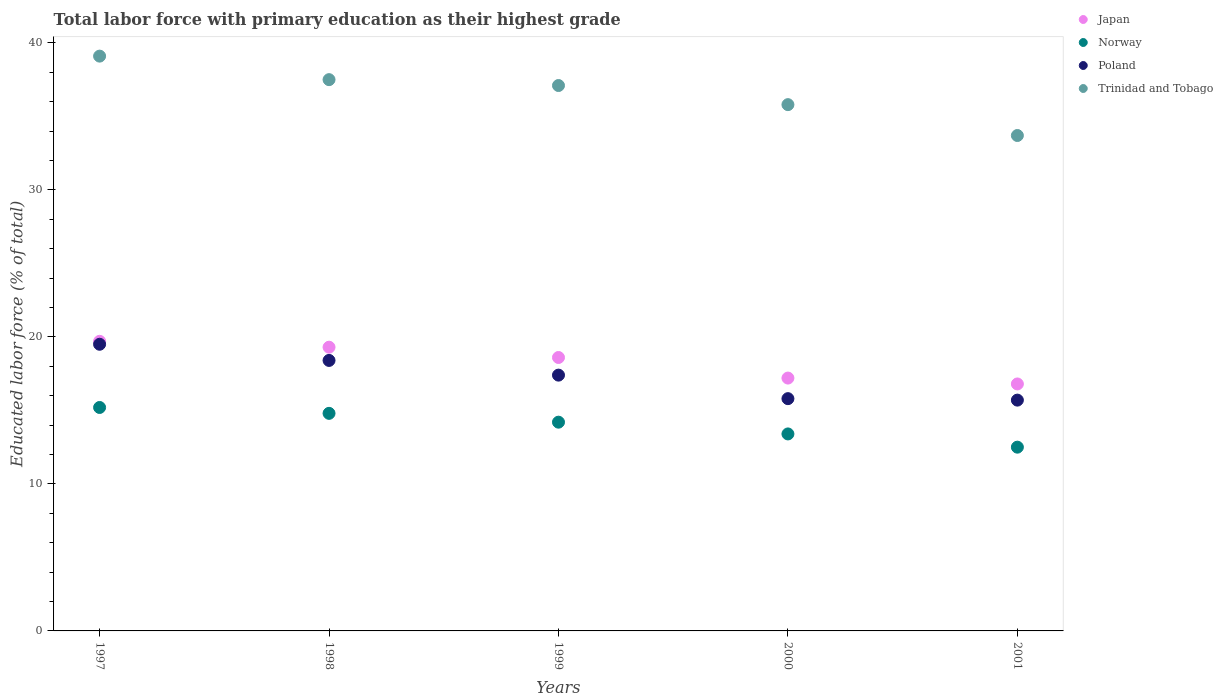What is the percentage of total labor force with primary education in Poland in 2000?
Make the answer very short. 15.8. Across all years, what is the maximum percentage of total labor force with primary education in Trinidad and Tobago?
Keep it short and to the point. 39.1. Across all years, what is the minimum percentage of total labor force with primary education in Trinidad and Tobago?
Offer a very short reply. 33.7. In which year was the percentage of total labor force with primary education in Norway maximum?
Give a very brief answer. 1997. In which year was the percentage of total labor force with primary education in Japan minimum?
Your answer should be compact. 2001. What is the total percentage of total labor force with primary education in Norway in the graph?
Give a very brief answer. 70.1. What is the difference between the percentage of total labor force with primary education in Trinidad and Tobago in 1998 and that in 2001?
Your answer should be very brief. 3.8. What is the difference between the percentage of total labor force with primary education in Japan in 2000 and the percentage of total labor force with primary education in Norway in 2001?
Provide a short and direct response. 4.7. What is the average percentage of total labor force with primary education in Japan per year?
Provide a succinct answer. 18.32. In the year 1997, what is the difference between the percentage of total labor force with primary education in Norway and percentage of total labor force with primary education in Japan?
Ensure brevity in your answer.  -4.5. In how many years, is the percentage of total labor force with primary education in Japan greater than 12 %?
Your answer should be very brief. 5. What is the ratio of the percentage of total labor force with primary education in Japan in 1998 to that in 1999?
Offer a terse response. 1.04. Is the percentage of total labor force with primary education in Poland in 1998 less than that in 2001?
Your answer should be very brief. No. What is the difference between the highest and the second highest percentage of total labor force with primary education in Poland?
Offer a very short reply. 1.1. What is the difference between the highest and the lowest percentage of total labor force with primary education in Norway?
Provide a short and direct response. 2.7. Is the sum of the percentage of total labor force with primary education in Trinidad and Tobago in 1997 and 1999 greater than the maximum percentage of total labor force with primary education in Japan across all years?
Offer a terse response. Yes. Is it the case that in every year, the sum of the percentage of total labor force with primary education in Norway and percentage of total labor force with primary education in Japan  is greater than the sum of percentage of total labor force with primary education in Trinidad and Tobago and percentage of total labor force with primary education in Poland?
Offer a very short reply. No. Is the percentage of total labor force with primary education in Poland strictly greater than the percentage of total labor force with primary education in Norway over the years?
Offer a terse response. Yes. How many dotlines are there?
Ensure brevity in your answer.  4. How many years are there in the graph?
Your answer should be compact. 5. What is the difference between two consecutive major ticks on the Y-axis?
Your answer should be very brief. 10. Are the values on the major ticks of Y-axis written in scientific E-notation?
Your response must be concise. No. Does the graph contain grids?
Offer a very short reply. No. Where does the legend appear in the graph?
Ensure brevity in your answer.  Top right. What is the title of the graph?
Ensure brevity in your answer.  Total labor force with primary education as their highest grade. Does "Germany" appear as one of the legend labels in the graph?
Give a very brief answer. No. What is the label or title of the Y-axis?
Ensure brevity in your answer.  Educated labor force (% of total). What is the Educated labor force (% of total) in Japan in 1997?
Keep it short and to the point. 19.7. What is the Educated labor force (% of total) in Norway in 1997?
Keep it short and to the point. 15.2. What is the Educated labor force (% of total) of Trinidad and Tobago in 1997?
Your response must be concise. 39.1. What is the Educated labor force (% of total) of Japan in 1998?
Your answer should be very brief. 19.3. What is the Educated labor force (% of total) of Norway in 1998?
Offer a very short reply. 14.8. What is the Educated labor force (% of total) in Poland in 1998?
Your response must be concise. 18.4. What is the Educated labor force (% of total) of Trinidad and Tobago in 1998?
Ensure brevity in your answer.  37.5. What is the Educated labor force (% of total) in Japan in 1999?
Give a very brief answer. 18.6. What is the Educated labor force (% of total) of Norway in 1999?
Offer a very short reply. 14.2. What is the Educated labor force (% of total) of Poland in 1999?
Your answer should be compact. 17.4. What is the Educated labor force (% of total) in Trinidad and Tobago in 1999?
Make the answer very short. 37.1. What is the Educated labor force (% of total) in Japan in 2000?
Your answer should be compact. 17.2. What is the Educated labor force (% of total) of Norway in 2000?
Ensure brevity in your answer.  13.4. What is the Educated labor force (% of total) of Poland in 2000?
Your response must be concise. 15.8. What is the Educated labor force (% of total) in Trinidad and Tobago in 2000?
Offer a terse response. 35.8. What is the Educated labor force (% of total) in Japan in 2001?
Offer a terse response. 16.8. What is the Educated labor force (% of total) of Norway in 2001?
Ensure brevity in your answer.  12.5. What is the Educated labor force (% of total) of Poland in 2001?
Provide a short and direct response. 15.7. What is the Educated labor force (% of total) in Trinidad and Tobago in 2001?
Give a very brief answer. 33.7. Across all years, what is the maximum Educated labor force (% of total) of Japan?
Provide a succinct answer. 19.7. Across all years, what is the maximum Educated labor force (% of total) of Norway?
Your answer should be very brief. 15.2. Across all years, what is the maximum Educated labor force (% of total) of Poland?
Your answer should be compact. 19.5. Across all years, what is the maximum Educated labor force (% of total) in Trinidad and Tobago?
Give a very brief answer. 39.1. Across all years, what is the minimum Educated labor force (% of total) of Japan?
Your response must be concise. 16.8. Across all years, what is the minimum Educated labor force (% of total) of Norway?
Make the answer very short. 12.5. Across all years, what is the minimum Educated labor force (% of total) in Poland?
Provide a succinct answer. 15.7. Across all years, what is the minimum Educated labor force (% of total) of Trinidad and Tobago?
Make the answer very short. 33.7. What is the total Educated labor force (% of total) of Japan in the graph?
Your answer should be very brief. 91.6. What is the total Educated labor force (% of total) in Norway in the graph?
Provide a succinct answer. 70.1. What is the total Educated labor force (% of total) of Poland in the graph?
Your answer should be compact. 86.8. What is the total Educated labor force (% of total) of Trinidad and Tobago in the graph?
Your answer should be compact. 183.2. What is the difference between the Educated labor force (% of total) in Norway in 1997 and that in 1998?
Your answer should be compact. 0.4. What is the difference between the Educated labor force (% of total) in Trinidad and Tobago in 1997 and that in 1998?
Your answer should be very brief. 1.6. What is the difference between the Educated labor force (% of total) of Norway in 1997 and that in 1999?
Offer a very short reply. 1. What is the difference between the Educated labor force (% of total) of Trinidad and Tobago in 1997 and that in 1999?
Your answer should be compact. 2. What is the difference between the Educated labor force (% of total) in Japan in 1997 and that in 2000?
Make the answer very short. 2.5. What is the difference between the Educated labor force (% of total) in Trinidad and Tobago in 1997 and that in 2000?
Offer a terse response. 3.3. What is the difference between the Educated labor force (% of total) in Trinidad and Tobago in 1997 and that in 2001?
Offer a very short reply. 5.4. What is the difference between the Educated labor force (% of total) in Japan in 1998 and that in 1999?
Provide a succinct answer. 0.7. What is the difference between the Educated labor force (% of total) in Norway in 1998 and that in 1999?
Keep it short and to the point. 0.6. What is the difference between the Educated labor force (% of total) of Trinidad and Tobago in 1998 and that in 1999?
Make the answer very short. 0.4. What is the difference between the Educated labor force (% of total) of Japan in 1998 and that in 2000?
Provide a short and direct response. 2.1. What is the difference between the Educated labor force (% of total) in Poland in 1998 and that in 2000?
Your response must be concise. 2.6. What is the difference between the Educated labor force (% of total) of Norway in 1998 and that in 2001?
Offer a terse response. 2.3. What is the difference between the Educated labor force (% of total) in Poland in 1998 and that in 2001?
Your response must be concise. 2.7. What is the difference between the Educated labor force (% of total) of Japan in 1999 and that in 2000?
Offer a terse response. 1.4. What is the difference between the Educated labor force (% of total) in Trinidad and Tobago in 1999 and that in 2000?
Ensure brevity in your answer.  1.3. What is the difference between the Educated labor force (% of total) in Japan in 1999 and that in 2001?
Keep it short and to the point. 1.8. What is the difference between the Educated labor force (% of total) in Norway in 1999 and that in 2001?
Your response must be concise. 1.7. What is the difference between the Educated labor force (% of total) of Trinidad and Tobago in 1999 and that in 2001?
Your answer should be compact. 3.4. What is the difference between the Educated labor force (% of total) of Japan in 2000 and that in 2001?
Ensure brevity in your answer.  0.4. What is the difference between the Educated labor force (% of total) in Poland in 2000 and that in 2001?
Your answer should be very brief. 0.1. What is the difference between the Educated labor force (% of total) of Japan in 1997 and the Educated labor force (% of total) of Poland in 1998?
Give a very brief answer. 1.3. What is the difference between the Educated labor force (% of total) in Japan in 1997 and the Educated labor force (% of total) in Trinidad and Tobago in 1998?
Your response must be concise. -17.8. What is the difference between the Educated labor force (% of total) in Norway in 1997 and the Educated labor force (% of total) in Poland in 1998?
Make the answer very short. -3.2. What is the difference between the Educated labor force (% of total) of Norway in 1997 and the Educated labor force (% of total) of Trinidad and Tobago in 1998?
Offer a very short reply. -22.3. What is the difference between the Educated labor force (% of total) in Japan in 1997 and the Educated labor force (% of total) in Poland in 1999?
Your answer should be compact. 2.3. What is the difference between the Educated labor force (% of total) of Japan in 1997 and the Educated labor force (% of total) of Trinidad and Tobago in 1999?
Provide a short and direct response. -17.4. What is the difference between the Educated labor force (% of total) in Norway in 1997 and the Educated labor force (% of total) in Trinidad and Tobago in 1999?
Offer a very short reply. -21.9. What is the difference between the Educated labor force (% of total) of Poland in 1997 and the Educated labor force (% of total) of Trinidad and Tobago in 1999?
Your answer should be very brief. -17.6. What is the difference between the Educated labor force (% of total) in Japan in 1997 and the Educated labor force (% of total) in Norway in 2000?
Provide a short and direct response. 6.3. What is the difference between the Educated labor force (% of total) in Japan in 1997 and the Educated labor force (% of total) in Poland in 2000?
Your answer should be compact. 3.9. What is the difference between the Educated labor force (% of total) of Japan in 1997 and the Educated labor force (% of total) of Trinidad and Tobago in 2000?
Keep it short and to the point. -16.1. What is the difference between the Educated labor force (% of total) of Norway in 1997 and the Educated labor force (% of total) of Trinidad and Tobago in 2000?
Make the answer very short. -20.6. What is the difference between the Educated labor force (% of total) in Poland in 1997 and the Educated labor force (% of total) in Trinidad and Tobago in 2000?
Give a very brief answer. -16.3. What is the difference between the Educated labor force (% of total) in Norway in 1997 and the Educated labor force (% of total) in Trinidad and Tobago in 2001?
Ensure brevity in your answer.  -18.5. What is the difference between the Educated labor force (% of total) of Japan in 1998 and the Educated labor force (% of total) of Poland in 1999?
Provide a succinct answer. 1.9. What is the difference between the Educated labor force (% of total) of Japan in 1998 and the Educated labor force (% of total) of Trinidad and Tobago in 1999?
Provide a succinct answer. -17.8. What is the difference between the Educated labor force (% of total) in Norway in 1998 and the Educated labor force (% of total) in Poland in 1999?
Offer a very short reply. -2.6. What is the difference between the Educated labor force (% of total) in Norway in 1998 and the Educated labor force (% of total) in Trinidad and Tobago in 1999?
Offer a terse response. -22.3. What is the difference between the Educated labor force (% of total) in Poland in 1998 and the Educated labor force (% of total) in Trinidad and Tobago in 1999?
Your answer should be compact. -18.7. What is the difference between the Educated labor force (% of total) of Japan in 1998 and the Educated labor force (% of total) of Norway in 2000?
Your answer should be compact. 5.9. What is the difference between the Educated labor force (% of total) of Japan in 1998 and the Educated labor force (% of total) of Trinidad and Tobago in 2000?
Ensure brevity in your answer.  -16.5. What is the difference between the Educated labor force (% of total) of Norway in 1998 and the Educated labor force (% of total) of Poland in 2000?
Your answer should be very brief. -1. What is the difference between the Educated labor force (% of total) of Poland in 1998 and the Educated labor force (% of total) of Trinidad and Tobago in 2000?
Your answer should be very brief. -17.4. What is the difference between the Educated labor force (% of total) in Japan in 1998 and the Educated labor force (% of total) in Trinidad and Tobago in 2001?
Offer a terse response. -14.4. What is the difference between the Educated labor force (% of total) in Norway in 1998 and the Educated labor force (% of total) in Trinidad and Tobago in 2001?
Your answer should be very brief. -18.9. What is the difference between the Educated labor force (% of total) of Poland in 1998 and the Educated labor force (% of total) of Trinidad and Tobago in 2001?
Your answer should be very brief. -15.3. What is the difference between the Educated labor force (% of total) of Japan in 1999 and the Educated labor force (% of total) of Poland in 2000?
Offer a very short reply. 2.8. What is the difference between the Educated labor force (% of total) in Japan in 1999 and the Educated labor force (% of total) in Trinidad and Tobago in 2000?
Your answer should be compact. -17.2. What is the difference between the Educated labor force (% of total) of Norway in 1999 and the Educated labor force (% of total) of Trinidad and Tobago in 2000?
Your response must be concise. -21.6. What is the difference between the Educated labor force (% of total) in Poland in 1999 and the Educated labor force (% of total) in Trinidad and Tobago in 2000?
Provide a succinct answer. -18.4. What is the difference between the Educated labor force (% of total) of Japan in 1999 and the Educated labor force (% of total) of Poland in 2001?
Provide a succinct answer. 2.9. What is the difference between the Educated labor force (% of total) of Japan in 1999 and the Educated labor force (% of total) of Trinidad and Tobago in 2001?
Your answer should be compact. -15.1. What is the difference between the Educated labor force (% of total) in Norway in 1999 and the Educated labor force (% of total) in Poland in 2001?
Provide a short and direct response. -1.5. What is the difference between the Educated labor force (% of total) in Norway in 1999 and the Educated labor force (% of total) in Trinidad and Tobago in 2001?
Offer a terse response. -19.5. What is the difference between the Educated labor force (% of total) in Poland in 1999 and the Educated labor force (% of total) in Trinidad and Tobago in 2001?
Give a very brief answer. -16.3. What is the difference between the Educated labor force (% of total) in Japan in 2000 and the Educated labor force (% of total) in Norway in 2001?
Give a very brief answer. 4.7. What is the difference between the Educated labor force (% of total) in Japan in 2000 and the Educated labor force (% of total) in Trinidad and Tobago in 2001?
Your answer should be very brief. -16.5. What is the difference between the Educated labor force (% of total) in Norway in 2000 and the Educated labor force (% of total) in Poland in 2001?
Your answer should be compact. -2.3. What is the difference between the Educated labor force (% of total) in Norway in 2000 and the Educated labor force (% of total) in Trinidad and Tobago in 2001?
Keep it short and to the point. -20.3. What is the difference between the Educated labor force (% of total) of Poland in 2000 and the Educated labor force (% of total) of Trinidad and Tobago in 2001?
Ensure brevity in your answer.  -17.9. What is the average Educated labor force (% of total) in Japan per year?
Your answer should be compact. 18.32. What is the average Educated labor force (% of total) of Norway per year?
Make the answer very short. 14.02. What is the average Educated labor force (% of total) in Poland per year?
Make the answer very short. 17.36. What is the average Educated labor force (% of total) in Trinidad and Tobago per year?
Your answer should be very brief. 36.64. In the year 1997, what is the difference between the Educated labor force (% of total) of Japan and Educated labor force (% of total) of Trinidad and Tobago?
Your answer should be very brief. -19.4. In the year 1997, what is the difference between the Educated labor force (% of total) of Norway and Educated labor force (% of total) of Poland?
Your response must be concise. -4.3. In the year 1997, what is the difference between the Educated labor force (% of total) of Norway and Educated labor force (% of total) of Trinidad and Tobago?
Offer a very short reply. -23.9. In the year 1997, what is the difference between the Educated labor force (% of total) in Poland and Educated labor force (% of total) in Trinidad and Tobago?
Keep it short and to the point. -19.6. In the year 1998, what is the difference between the Educated labor force (% of total) of Japan and Educated labor force (% of total) of Norway?
Make the answer very short. 4.5. In the year 1998, what is the difference between the Educated labor force (% of total) in Japan and Educated labor force (% of total) in Poland?
Ensure brevity in your answer.  0.9. In the year 1998, what is the difference between the Educated labor force (% of total) in Japan and Educated labor force (% of total) in Trinidad and Tobago?
Provide a succinct answer. -18.2. In the year 1998, what is the difference between the Educated labor force (% of total) in Norway and Educated labor force (% of total) in Poland?
Offer a terse response. -3.6. In the year 1998, what is the difference between the Educated labor force (% of total) of Norway and Educated labor force (% of total) of Trinidad and Tobago?
Offer a terse response. -22.7. In the year 1998, what is the difference between the Educated labor force (% of total) of Poland and Educated labor force (% of total) of Trinidad and Tobago?
Your answer should be very brief. -19.1. In the year 1999, what is the difference between the Educated labor force (% of total) of Japan and Educated labor force (% of total) of Poland?
Your response must be concise. 1.2. In the year 1999, what is the difference between the Educated labor force (% of total) in Japan and Educated labor force (% of total) in Trinidad and Tobago?
Offer a very short reply. -18.5. In the year 1999, what is the difference between the Educated labor force (% of total) of Norway and Educated labor force (% of total) of Poland?
Your answer should be very brief. -3.2. In the year 1999, what is the difference between the Educated labor force (% of total) of Norway and Educated labor force (% of total) of Trinidad and Tobago?
Provide a succinct answer. -22.9. In the year 1999, what is the difference between the Educated labor force (% of total) in Poland and Educated labor force (% of total) in Trinidad and Tobago?
Your answer should be very brief. -19.7. In the year 2000, what is the difference between the Educated labor force (% of total) in Japan and Educated labor force (% of total) in Poland?
Provide a short and direct response. 1.4. In the year 2000, what is the difference between the Educated labor force (% of total) in Japan and Educated labor force (% of total) in Trinidad and Tobago?
Keep it short and to the point. -18.6. In the year 2000, what is the difference between the Educated labor force (% of total) of Norway and Educated labor force (% of total) of Trinidad and Tobago?
Your answer should be very brief. -22.4. In the year 2001, what is the difference between the Educated labor force (% of total) in Japan and Educated labor force (% of total) in Trinidad and Tobago?
Provide a succinct answer. -16.9. In the year 2001, what is the difference between the Educated labor force (% of total) of Norway and Educated labor force (% of total) of Trinidad and Tobago?
Your response must be concise. -21.2. What is the ratio of the Educated labor force (% of total) in Japan in 1997 to that in 1998?
Your answer should be very brief. 1.02. What is the ratio of the Educated labor force (% of total) of Norway in 1997 to that in 1998?
Ensure brevity in your answer.  1.03. What is the ratio of the Educated labor force (% of total) in Poland in 1997 to that in 1998?
Ensure brevity in your answer.  1.06. What is the ratio of the Educated labor force (% of total) in Trinidad and Tobago in 1997 to that in 1998?
Provide a short and direct response. 1.04. What is the ratio of the Educated labor force (% of total) in Japan in 1997 to that in 1999?
Provide a succinct answer. 1.06. What is the ratio of the Educated labor force (% of total) in Norway in 1997 to that in 1999?
Offer a very short reply. 1.07. What is the ratio of the Educated labor force (% of total) of Poland in 1997 to that in 1999?
Keep it short and to the point. 1.12. What is the ratio of the Educated labor force (% of total) in Trinidad and Tobago in 1997 to that in 1999?
Keep it short and to the point. 1.05. What is the ratio of the Educated labor force (% of total) in Japan in 1997 to that in 2000?
Your answer should be very brief. 1.15. What is the ratio of the Educated labor force (% of total) in Norway in 1997 to that in 2000?
Ensure brevity in your answer.  1.13. What is the ratio of the Educated labor force (% of total) of Poland in 1997 to that in 2000?
Your response must be concise. 1.23. What is the ratio of the Educated labor force (% of total) of Trinidad and Tobago in 1997 to that in 2000?
Offer a very short reply. 1.09. What is the ratio of the Educated labor force (% of total) in Japan in 1997 to that in 2001?
Provide a succinct answer. 1.17. What is the ratio of the Educated labor force (% of total) of Norway in 1997 to that in 2001?
Your response must be concise. 1.22. What is the ratio of the Educated labor force (% of total) in Poland in 1997 to that in 2001?
Your answer should be very brief. 1.24. What is the ratio of the Educated labor force (% of total) in Trinidad and Tobago in 1997 to that in 2001?
Offer a very short reply. 1.16. What is the ratio of the Educated labor force (% of total) of Japan in 1998 to that in 1999?
Your answer should be very brief. 1.04. What is the ratio of the Educated labor force (% of total) in Norway in 1998 to that in 1999?
Offer a terse response. 1.04. What is the ratio of the Educated labor force (% of total) of Poland in 1998 to that in 1999?
Offer a very short reply. 1.06. What is the ratio of the Educated labor force (% of total) of Trinidad and Tobago in 1998 to that in 1999?
Your response must be concise. 1.01. What is the ratio of the Educated labor force (% of total) in Japan in 1998 to that in 2000?
Provide a succinct answer. 1.12. What is the ratio of the Educated labor force (% of total) of Norway in 1998 to that in 2000?
Provide a short and direct response. 1.1. What is the ratio of the Educated labor force (% of total) of Poland in 1998 to that in 2000?
Provide a succinct answer. 1.16. What is the ratio of the Educated labor force (% of total) of Trinidad and Tobago in 1998 to that in 2000?
Your answer should be very brief. 1.05. What is the ratio of the Educated labor force (% of total) in Japan in 1998 to that in 2001?
Offer a very short reply. 1.15. What is the ratio of the Educated labor force (% of total) in Norway in 1998 to that in 2001?
Ensure brevity in your answer.  1.18. What is the ratio of the Educated labor force (% of total) in Poland in 1998 to that in 2001?
Offer a terse response. 1.17. What is the ratio of the Educated labor force (% of total) of Trinidad and Tobago in 1998 to that in 2001?
Provide a succinct answer. 1.11. What is the ratio of the Educated labor force (% of total) of Japan in 1999 to that in 2000?
Your answer should be compact. 1.08. What is the ratio of the Educated labor force (% of total) in Norway in 1999 to that in 2000?
Provide a succinct answer. 1.06. What is the ratio of the Educated labor force (% of total) in Poland in 1999 to that in 2000?
Ensure brevity in your answer.  1.1. What is the ratio of the Educated labor force (% of total) in Trinidad and Tobago in 1999 to that in 2000?
Provide a short and direct response. 1.04. What is the ratio of the Educated labor force (% of total) of Japan in 1999 to that in 2001?
Offer a very short reply. 1.11. What is the ratio of the Educated labor force (% of total) of Norway in 1999 to that in 2001?
Offer a very short reply. 1.14. What is the ratio of the Educated labor force (% of total) in Poland in 1999 to that in 2001?
Give a very brief answer. 1.11. What is the ratio of the Educated labor force (% of total) in Trinidad and Tobago in 1999 to that in 2001?
Offer a terse response. 1.1. What is the ratio of the Educated labor force (% of total) of Japan in 2000 to that in 2001?
Give a very brief answer. 1.02. What is the ratio of the Educated labor force (% of total) in Norway in 2000 to that in 2001?
Offer a very short reply. 1.07. What is the ratio of the Educated labor force (% of total) in Poland in 2000 to that in 2001?
Offer a very short reply. 1.01. What is the ratio of the Educated labor force (% of total) in Trinidad and Tobago in 2000 to that in 2001?
Your answer should be compact. 1.06. What is the difference between the highest and the second highest Educated labor force (% of total) of Japan?
Your answer should be compact. 0.4. What is the difference between the highest and the second highest Educated labor force (% of total) in Norway?
Provide a succinct answer. 0.4. What is the difference between the highest and the second highest Educated labor force (% of total) in Poland?
Make the answer very short. 1.1. What is the difference between the highest and the second highest Educated labor force (% of total) in Trinidad and Tobago?
Keep it short and to the point. 1.6. 